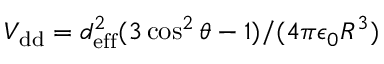Convert formula to latex. <formula><loc_0><loc_0><loc_500><loc_500>V _ { d d } = d _ { e f f } ^ { 2 } ( 3 \cos ^ { 2 } \theta - 1 ) / ( 4 \pi \epsilon _ { 0 } R ^ { 3 } )</formula> 